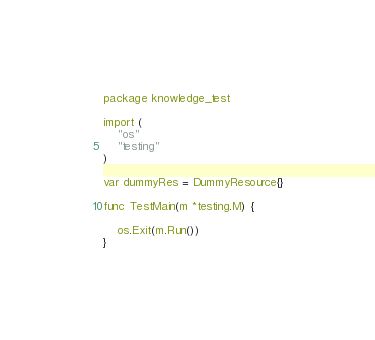<code> <loc_0><loc_0><loc_500><loc_500><_Go_>package knowledge_test

import (
	"os"
	"testing"
)

var dummyRes = DummyResource{}

func TestMain(m *testing.M) {

	os.Exit(m.Run())
}
</code> 